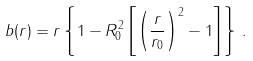Convert formula to latex. <formula><loc_0><loc_0><loc_500><loc_500>b ( r ) = r \left \{ 1 - R _ { 0 } ^ { 2 } \left [ \left ( \frac { r } { r _ { 0 } } \right ) ^ { 2 } - 1 \right ] \right \} \, .</formula> 